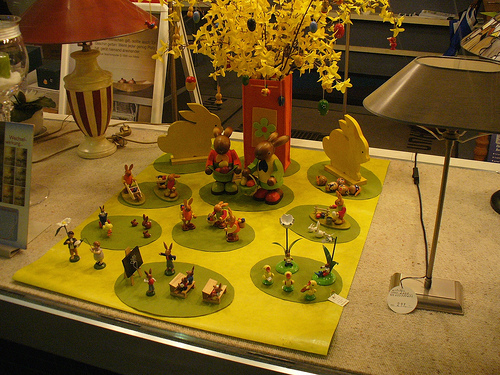<image>
Is there a egg on the flower? Yes. Looking at the image, I can see the egg is positioned on top of the flower, with the flower providing support. 